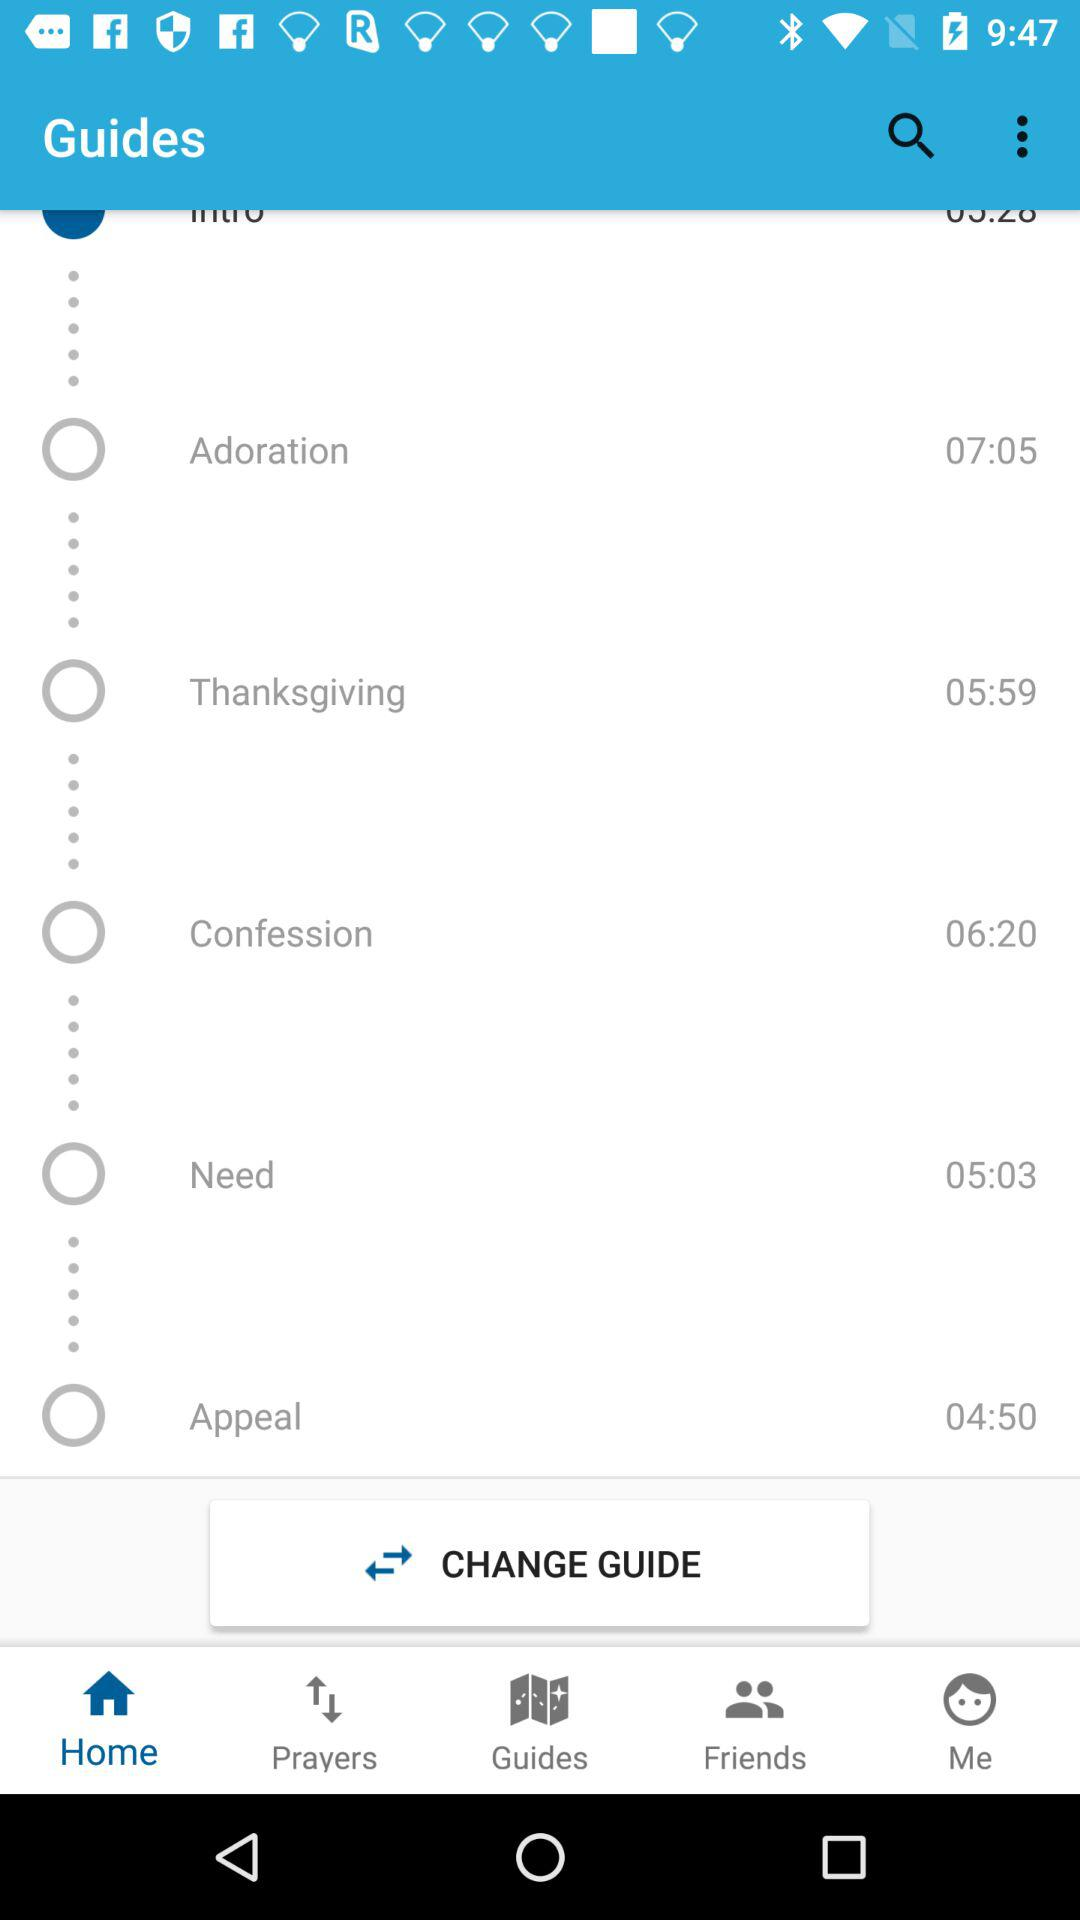What's the timing for "Adoration"? The timing for "Adoration" is 07:05. 